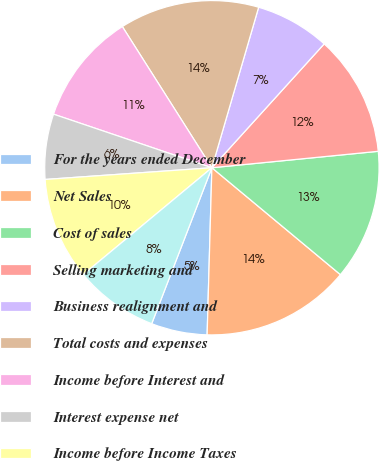Convert chart to OTSL. <chart><loc_0><loc_0><loc_500><loc_500><pie_chart><fcel>For the years ended December<fcel>Net Sales<fcel>Cost of sales<fcel>Selling marketing and<fcel>Business realignment and<fcel>Total costs and expenses<fcel>Income before Interest and<fcel>Interest expense net<fcel>Income before Income Taxes<fcel>Provision for income taxes<nl><fcel>5.41%<fcel>14.41%<fcel>12.61%<fcel>11.71%<fcel>7.21%<fcel>13.51%<fcel>10.81%<fcel>6.31%<fcel>9.91%<fcel>8.11%<nl></chart> 